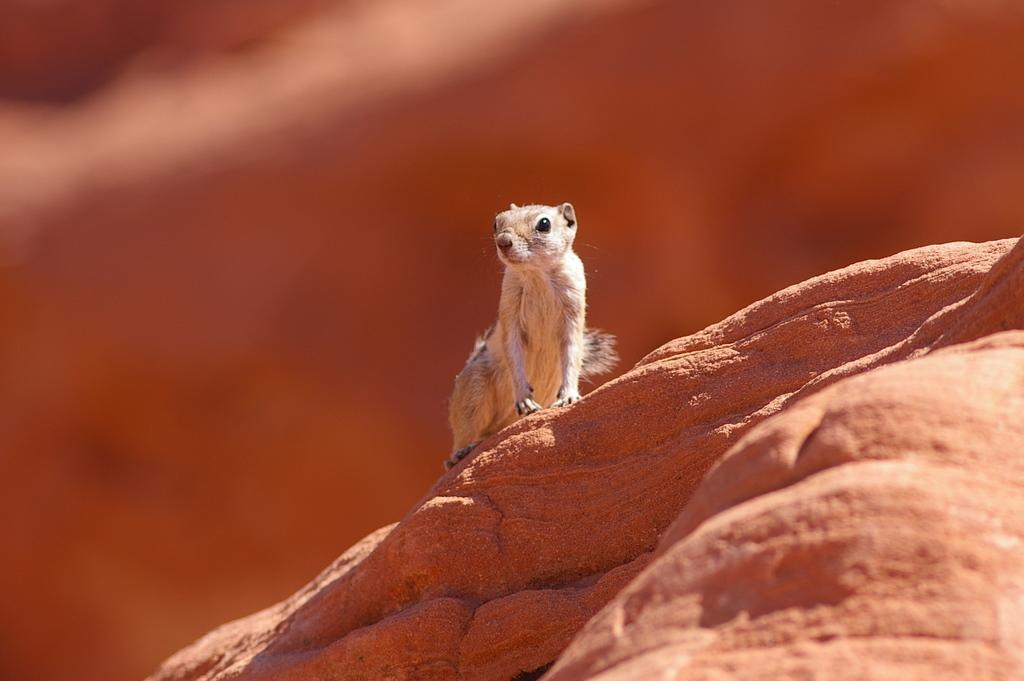In one or two sentences, can you explain what this image depicts? In the middle of this image there is a squirrel on a rock. The background is blurred. 